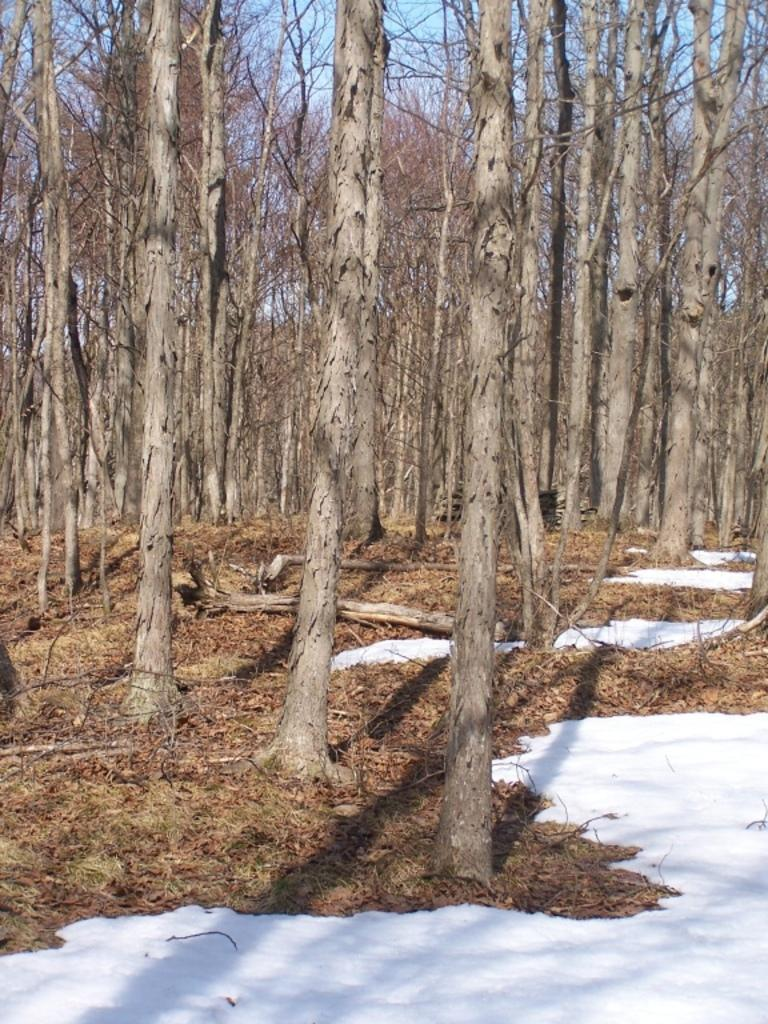What type of trees are visible in the image? There are dry trees in the image. Where are the trees located? The trees are on a land. What is the weather condition in the image? There is snow present in the image, indicating a cold or wintery condition. What type of quartz can be seen on the shoes of the bee in the image? There are no bees or shoes present in the image, and quartz is a mineral, not an item of clothing for insects. 